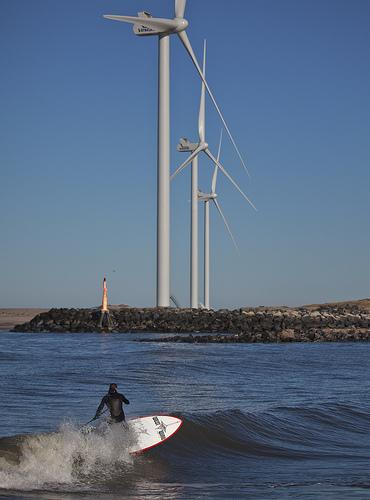What is the primary happening occurring in the picture? A male surfer paddling a red-trimmed white surfboard on a wave by the shore. In few words, narrate the core scene of this image. Surfer conquering a wave on his red and white paddleboard near the coast. Briefly describe the content of the image, emphasizing the main figure. Surfer in a black wetsuit on a red-bordered white surfboard, masterfully riding a wave. Highlight the most important action taking place in the image. Male surfer skillfully riding an ocean wave on a red and white surfboard with a paddle. Briefly explain the focal point in the image. A surfer is riding a wave on a red and white surfboard, using a paddle for balance. Describe the key activity in the image using few words. Surfer riding a wave on a paddleboard near a rocky beach. Concisely explain the key component of the image and what it's doing. Man maneuvering a wave on a paddleboard, wearing a black wetsuit and using a paddle. Write a concise image summary focusing on the main object. Surfer wearing a black wetsuit, catching a wave on a red and white surfboard with a paddle. Provide a succinct description of the central subject in this image. A man in a black wetsuit on a paddleboard navigating a wave near a rocky shore. Please mention the notable elements of this image. Man on surfboard, paddling on a wave, rocky shoreline, and wind turbines in the background. 